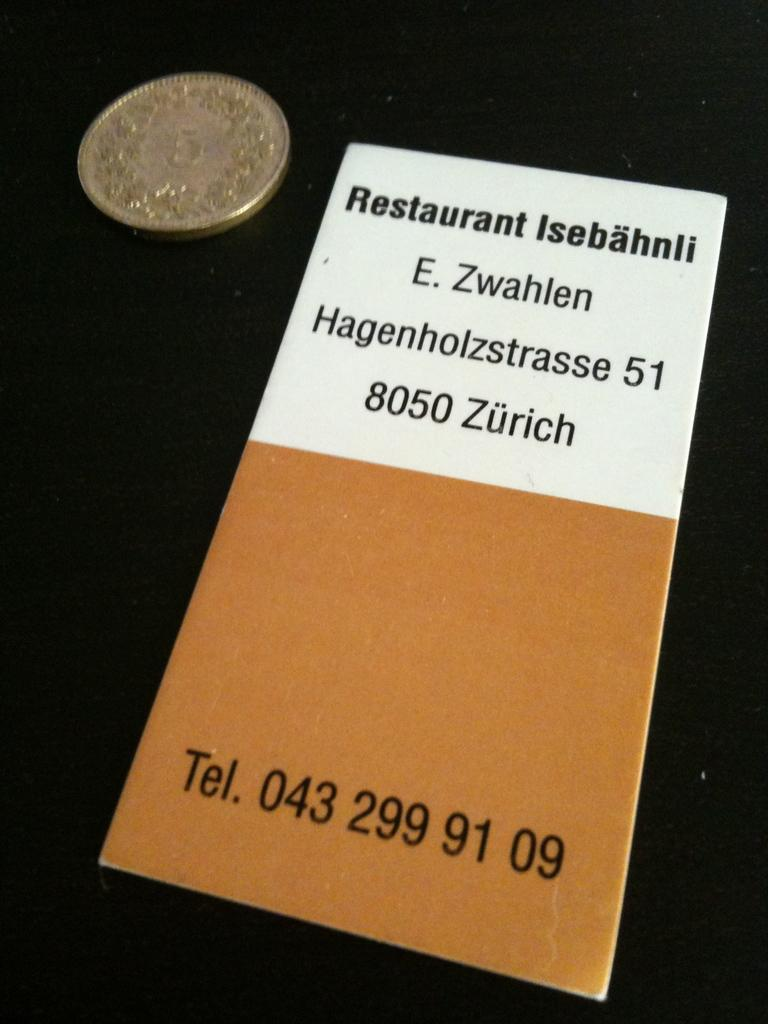<image>
Give a short and clear explanation of the subsequent image. A pamphlet titled Restaurant Isebahnli and the address E. Zwahlen Hagenholzstrasse 51 8050 Zurich and the telephone number 043 299 91 09 